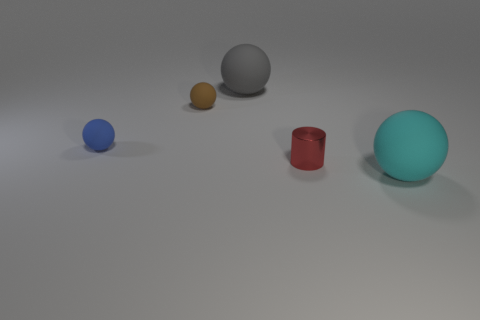Subtract all brown balls. How many balls are left? 3 Subtract all cyan balls. How many balls are left? 3 Subtract all spheres. How many objects are left? 1 Add 2 red metal things. How many objects exist? 7 Subtract 0 blue cubes. How many objects are left? 5 Subtract 2 balls. How many balls are left? 2 Subtract all blue balls. Subtract all blue cubes. How many balls are left? 3 Subtract all brown cylinders. How many cyan balls are left? 1 Subtract all large cyan rubber cylinders. Subtract all gray rubber spheres. How many objects are left? 4 Add 5 gray matte spheres. How many gray matte spheres are left? 6 